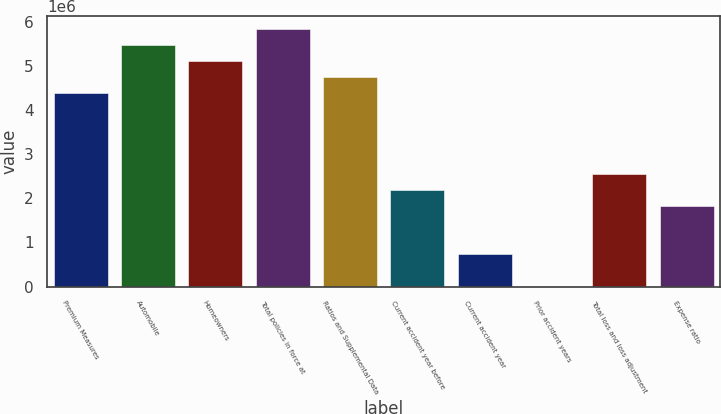Convert chart to OTSL. <chart><loc_0><loc_0><loc_500><loc_500><bar_chart><fcel>Premium Measures<fcel>Automobile<fcel>Homeowners<fcel>Total policies in force at<fcel>Ratios and Supplemental Data<fcel>Current accident year before<fcel>Current accident year<fcel>Prior accident years<fcel>Total loss and loss adjustment<fcel>Expense ratio<nl><fcel>4.38295e+06<fcel>5.47869e+06<fcel>5.11344e+06<fcel>5.84393e+06<fcel>4.74819e+06<fcel>2.19148e+06<fcel>730493<fcel>2.2<fcel>2.55672e+06<fcel>1.82623e+06<nl></chart> 